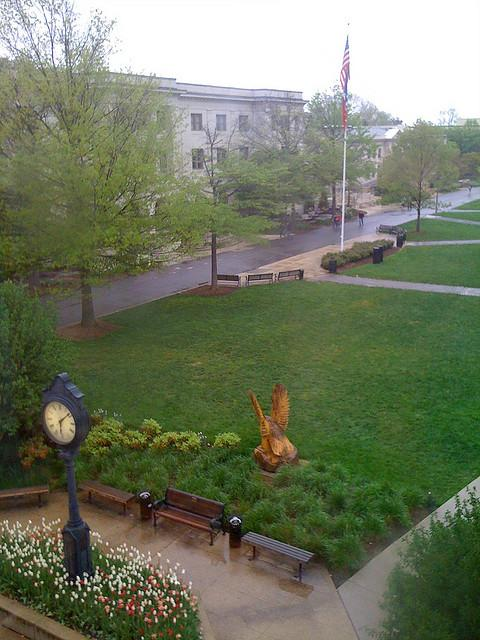What might someone need if they are walking by this clock? Please explain your reasoning. umbrella. A hazy rain can be seen in an area near a clock. 